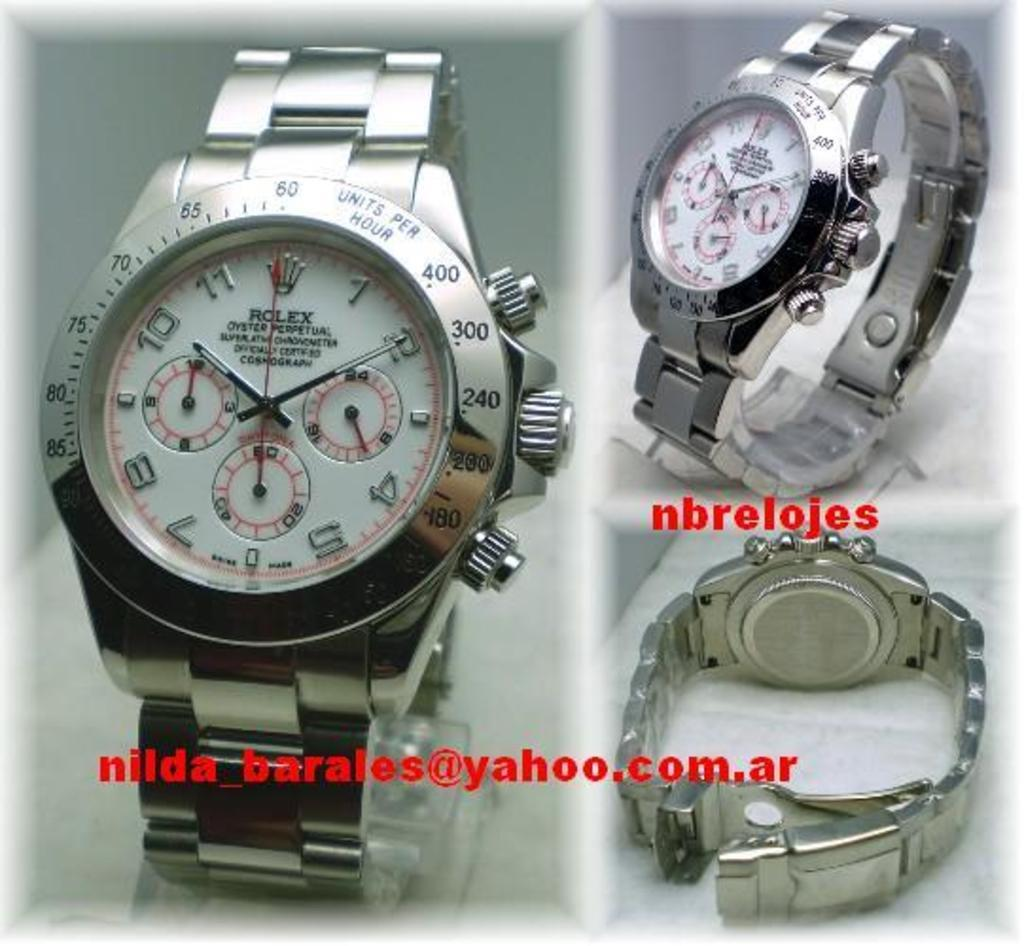Provide a one-sentence caption for the provided image. a rolex watch is shown from three angles. 